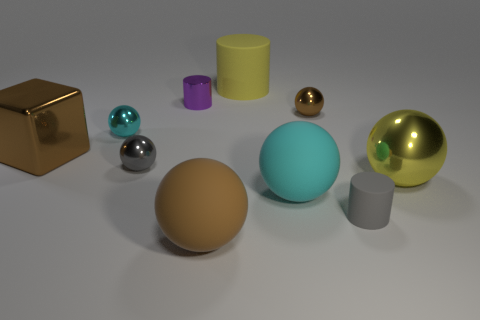There is a large matte object that is the same color as the large shiny cube; what is its shape?
Ensure brevity in your answer.  Sphere. What is the color of the block that is the same size as the yellow ball?
Make the answer very short. Brown. What is the ball to the right of the small brown object made of?
Your answer should be compact. Metal. The thing that is in front of the big cyan matte thing and on the right side of the big yellow cylinder is made of what material?
Ensure brevity in your answer.  Rubber. There is a sphere that is in front of the gray matte cylinder; is it the same size as the tiny rubber thing?
Offer a terse response. No. What shape is the yellow matte thing?
Offer a terse response. Cylinder. What number of other big rubber objects have the same shape as the gray rubber thing?
Offer a terse response. 1. What number of metallic things are both in front of the tiny purple cylinder and on the left side of the large brown rubber thing?
Provide a short and direct response. 3. The big cube is what color?
Keep it short and to the point. Brown. Is there a large yellow thing that has the same material as the small brown object?
Ensure brevity in your answer.  Yes. 